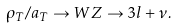Convert formula to latex. <formula><loc_0><loc_0><loc_500><loc_500>\rho _ { T } / a _ { T } \rightarrow W Z \rightarrow 3 l + \nu .</formula> 